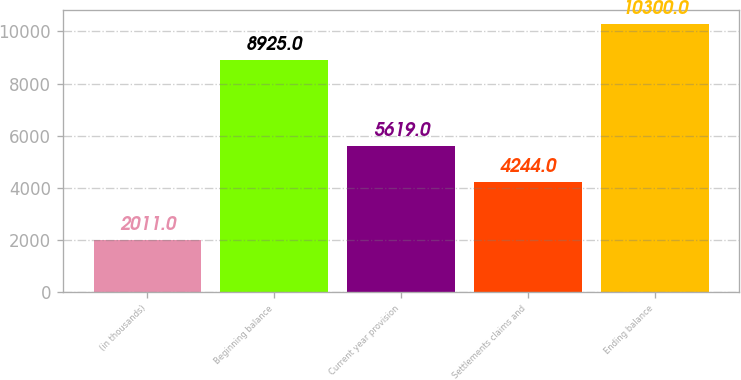<chart> <loc_0><loc_0><loc_500><loc_500><bar_chart><fcel>(in thousands)<fcel>Beginning balance<fcel>Current year provision<fcel>Settlements claims and<fcel>Ending balance<nl><fcel>2011<fcel>8925<fcel>5619<fcel>4244<fcel>10300<nl></chart> 